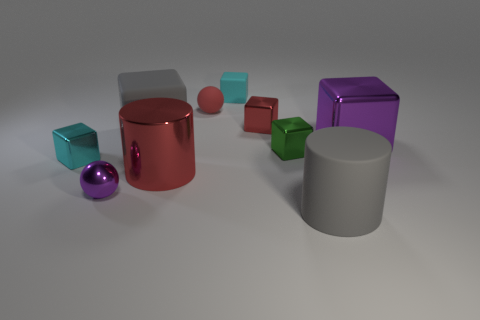Is the red matte object the same size as the purple ball?
Offer a very short reply. Yes. Are there any large gray matte blocks in front of the tiny matte object that is on the right side of the red matte sphere?
Provide a short and direct response. Yes. There is a object that is the same color as the tiny metal ball; what is its size?
Offer a terse response. Large. The red metallic object on the right side of the large red metal cylinder has what shape?
Ensure brevity in your answer.  Cube. What number of tiny green cubes are in front of the gray rubber thing that is to the left of the rubber cylinder that is in front of the tiny red ball?
Keep it short and to the point. 1. There is a cyan metal object; does it have the same size as the red thing that is in front of the purple block?
Your answer should be compact. No. There is a purple metal object that is on the right side of the red shiny thing behind the cyan metal block; how big is it?
Give a very brief answer. Large. What number of small cyan objects have the same material as the purple block?
Ensure brevity in your answer.  1. Are there any tiny matte objects?
Offer a terse response. Yes. What size is the purple thing on the right side of the big red cylinder?
Your response must be concise. Large. 